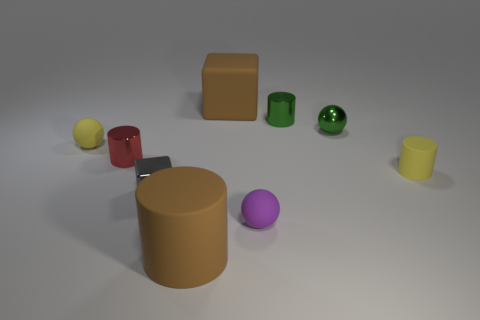Subtract all metal balls. How many balls are left? 2 Add 1 small spheres. How many objects exist? 10 Subtract all brown cylinders. How many cylinders are left? 3 Subtract all balls. How many objects are left? 6 Subtract all purple cubes. Subtract all red metallic things. How many objects are left? 8 Add 7 small shiny blocks. How many small shiny blocks are left? 8 Add 7 large green cylinders. How many large green cylinders exist? 7 Subtract 0 red balls. How many objects are left? 9 Subtract all purple cylinders. Subtract all gray spheres. How many cylinders are left? 4 